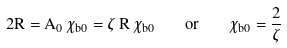<formula> <loc_0><loc_0><loc_500><loc_500>2 R = A _ { 0 } \, \chi _ { b 0 } = \zeta \, R \, \chi _ { b 0 } \quad o r \quad \chi _ { b 0 } = \frac { 2 } { \zeta }</formula> 